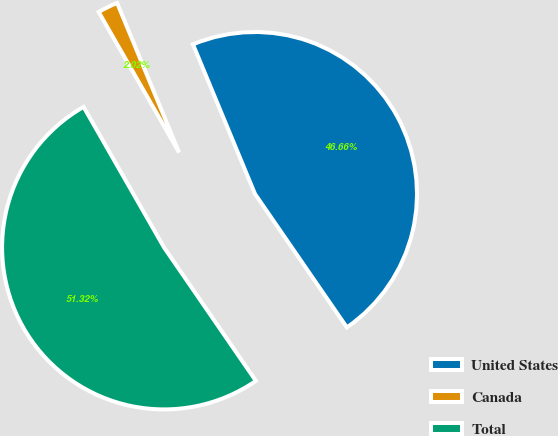Convert chart. <chart><loc_0><loc_0><loc_500><loc_500><pie_chart><fcel>United States<fcel>Canada<fcel>Total<nl><fcel>46.66%<fcel>2.02%<fcel>51.32%<nl></chart> 